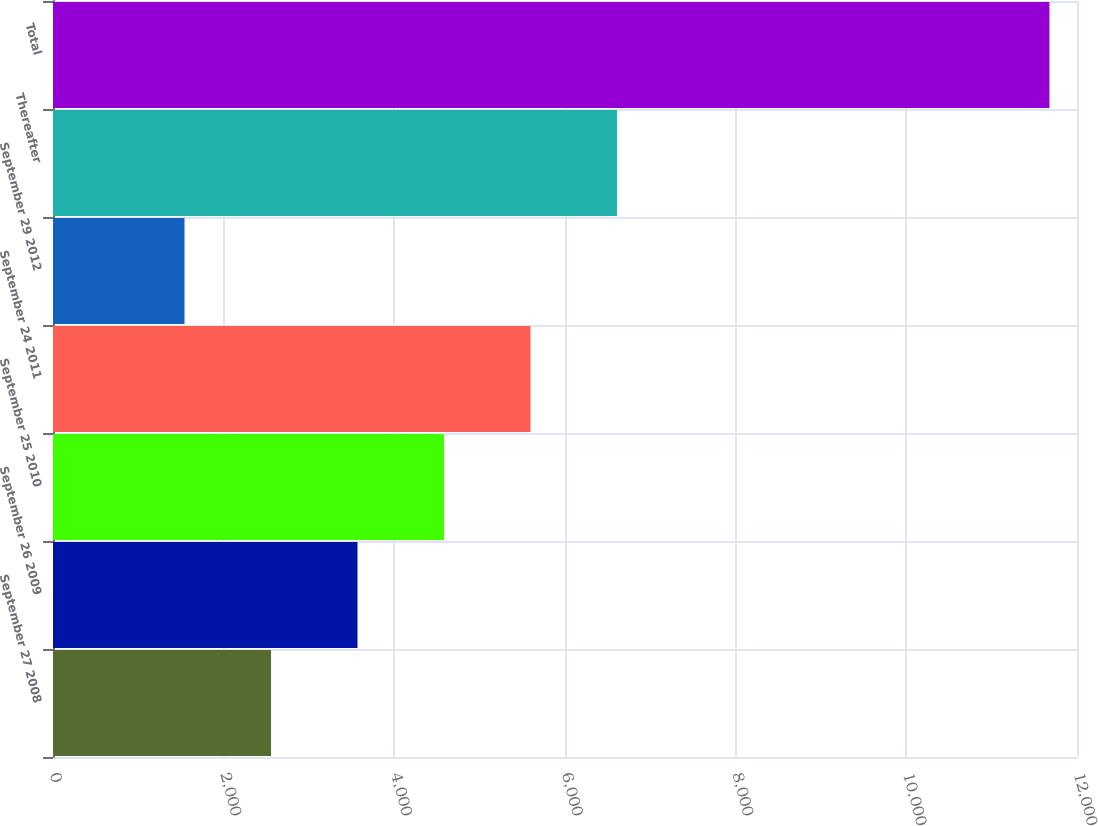Convert chart to OTSL. <chart><loc_0><loc_0><loc_500><loc_500><bar_chart><fcel>September 27 2008<fcel>September 26 2009<fcel>September 25 2010<fcel>September 24 2011<fcel>September 29 2012<fcel>Thereafter<fcel>Total<nl><fcel>2554.6<fcel>3568.2<fcel>4581.8<fcel>5595.4<fcel>1541<fcel>6609<fcel>11677<nl></chart> 